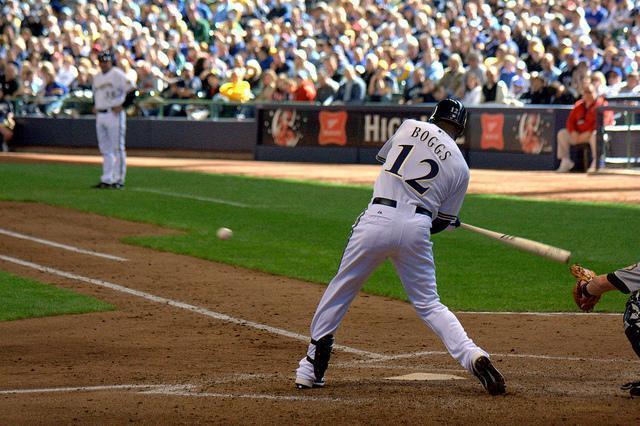Why cricketers wear white?
Make your selection from the four choices given to correctly answer the question.
Options: Reduces heat, peace, unique, dress code. Reduces heat. 